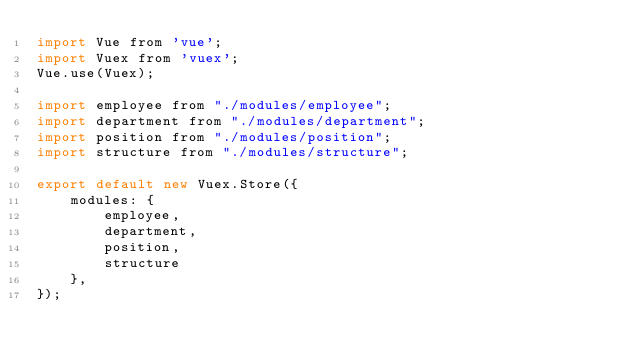<code> <loc_0><loc_0><loc_500><loc_500><_JavaScript_>import Vue from 'vue';
import Vuex from 'vuex';
Vue.use(Vuex);

import employee from "./modules/employee";
import department from "./modules/department";
import position from "./modules/position";
import structure from "./modules/structure";

export default new Vuex.Store({
    modules: {
        employee,
        department,
        position,
        structure
    },
});
</code> 